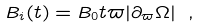Convert formula to latex. <formula><loc_0><loc_0><loc_500><loc_500>B _ { i } ( t ) = B _ { 0 } t \varpi | \partial _ { \varpi } \Omega | \ ,</formula> 